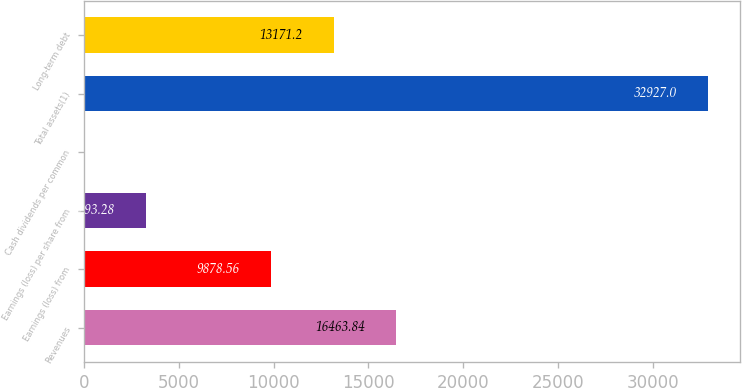Convert chart. <chart><loc_0><loc_0><loc_500><loc_500><bar_chart><fcel>Revenues<fcel>Earnings (loss) from<fcel>Earnings (loss) per share from<fcel>Cash dividends per common<fcel>Total assets(1)<fcel>Long-term debt<nl><fcel>16463.8<fcel>9878.56<fcel>3293.28<fcel>0.64<fcel>32927<fcel>13171.2<nl></chart> 